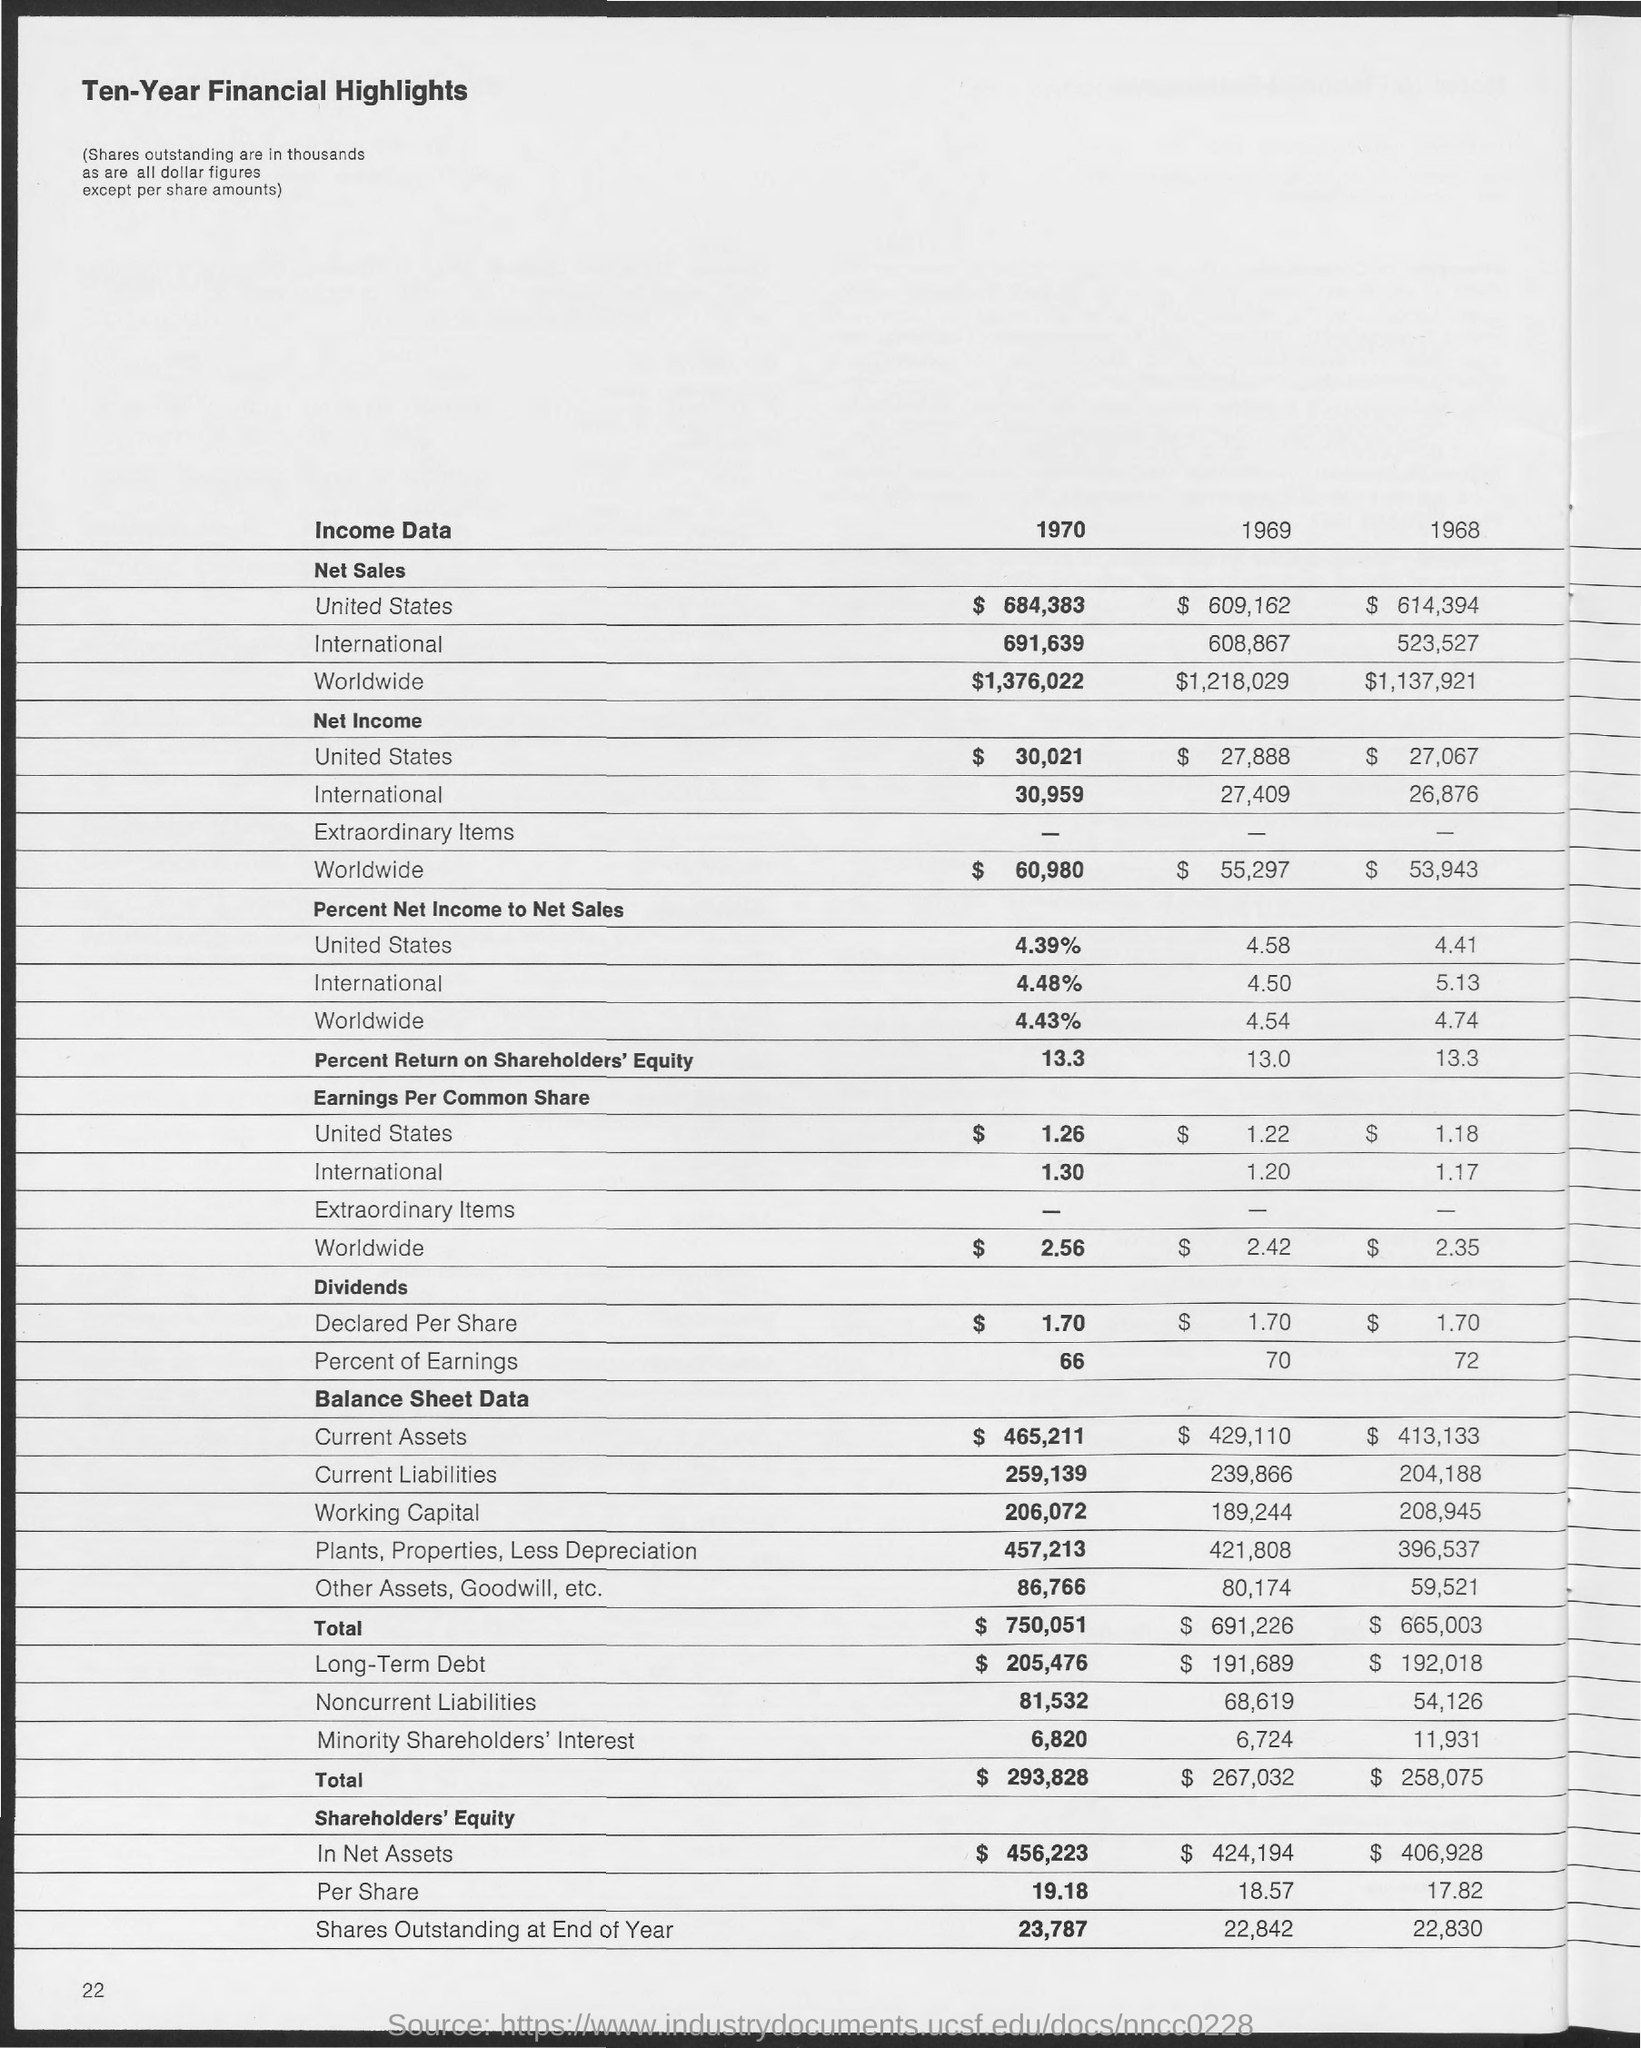What is the net sales for United States in 1970?
Offer a very short reply. $684,383. What is the net sales for United States in 1969?
Offer a very short reply. $ 609,162. What is the net sales for United States in 1968?
Ensure brevity in your answer.  $614,394. What is the net sales for International in 1970?
Offer a terse response. 691,639. What is the net sales for International in 1969?
Keep it short and to the point. 608,867. What is the net sales for International in 1968?
Provide a succinct answer. 523,527. What is the net sales for Worldwide in 1970?
Keep it short and to the point. $1,376,022. What is the net sales for Worldwide in 1969?
Give a very brief answer. $1,218,029. What is the net sales for Worldwide in 1968?
Ensure brevity in your answer.  $1,137,921. What is the net income for Worldwide in 1970?
Provide a short and direct response. $ 60,980. 